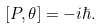Convert formula to latex. <formula><loc_0><loc_0><loc_500><loc_500>[ P , \theta ] = - i \hbar { . }</formula> 